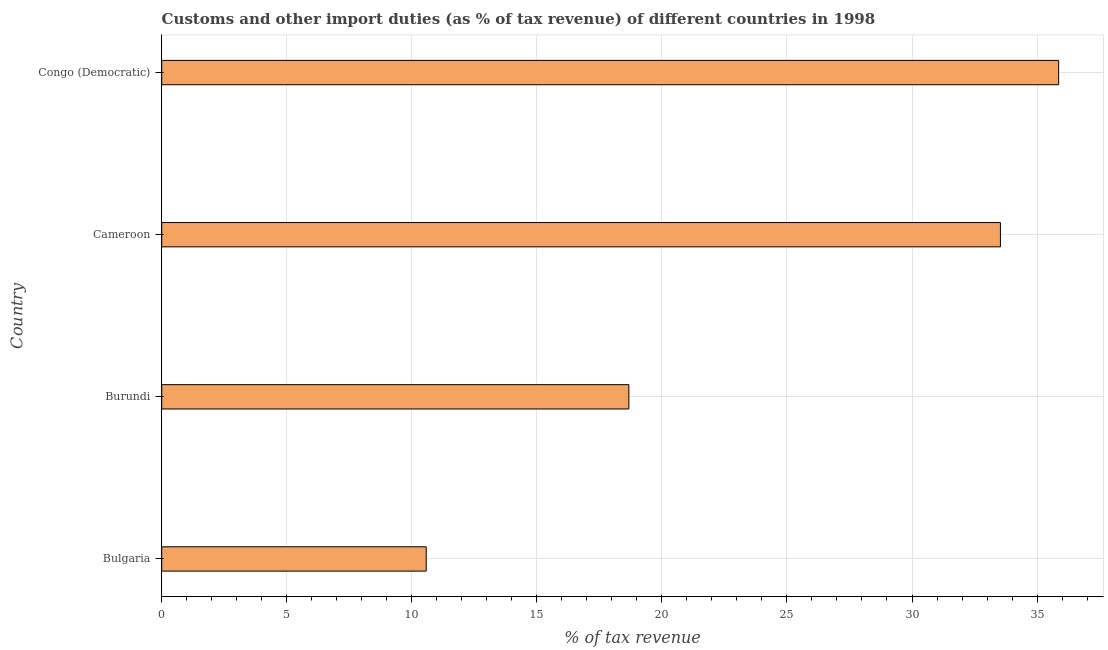Does the graph contain any zero values?
Keep it short and to the point. No. What is the title of the graph?
Keep it short and to the point. Customs and other import duties (as % of tax revenue) of different countries in 1998. What is the label or title of the X-axis?
Provide a succinct answer. % of tax revenue. What is the label or title of the Y-axis?
Give a very brief answer. Country. What is the customs and other import duties in Congo (Democratic)?
Offer a very short reply. 35.86. Across all countries, what is the maximum customs and other import duties?
Your answer should be very brief. 35.86. Across all countries, what is the minimum customs and other import duties?
Provide a short and direct response. 10.58. In which country was the customs and other import duties maximum?
Offer a terse response. Congo (Democratic). In which country was the customs and other import duties minimum?
Ensure brevity in your answer.  Bulgaria. What is the sum of the customs and other import duties?
Your answer should be very brief. 98.65. What is the difference between the customs and other import duties in Burundi and Congo (Democratic)?
Offer a very short reply. -17.18. What is the average customs and other import duties per country?
Your answer should be compact. 24.66. What is the median customs and other import duties?
Your response must be concise. 26.11. What is the ratio of the customs and other import duties in Burundi to that in Cameroon?
Make the answer very short. 0.56. Is the difference between the customs and other import duties in Burundi and Congo (Democratic) greater than the difference between any two countries?
Provide a succinct answer. No. What is the difference between the highest and the second highest customs and other import duties?
Give a very brief answer. 2.33. What is the difference between the highest and the lowest customs and other import duties?
Make the answer very short. 25.29. How many bars are there?
Your answer should be very brief. 4. How many countries are there in the graph?
Offer a very short reply. 4. What is the difference between two consecutive major ticks on the X-axis?
Offer a very short reply. 5. Are the values on the major ticks of X-axis written in scientific E-notation?
Provide a short and direct response. No. What is the % of tax revenue in Bulgaria?
Your response must be concise. 10.58. What is the % of tax revenue in Burundi?
Your answer should be compact. 18.68. What is the % of tax revenue of Cameroon?
Give a very brief answer. 33.54. What is the % of tax revenue of Congo (Democratic)?
Your answer should be very brief. 35.86. What is the difference between the % of tax revenue in Bulgaria and Burundi?
Your answer should be compact. -8.1. What is the difference between the % of tax revenue in Bulgaria and Cameroon?
Your response must be concise. -22.96. What is the difference between the % of tax revenue in Bulgaria and Congo (Democratic)?
Your answer should be very brief. -25.29. What is the difference between the % of tax revenue in Burundi and Cameroon?
Keep it short and to the point. -14.86. What is the difference between the % of tax revenue in Burundi and Congo (Democratic)?
Provide a succinct answer. -17.18. What is the difference between the % of tax revenue in Cameroon and Congo (Democratic)?
Give a very brief answer. -2.33. What is the ratio of the % of tax revenue in Bulgaria to that in Burundi?
Give a very brief answer. 0.57. What is the ratio of the % of tax revenue in Bulgaria to that in Cameroon?
Give a very brief answer. 0.32. What is the ratio of the % of tax revenue in Bulgaria to that in Congo (Democratic)?
Ensure brevity in your answer.  0.29. What is the ratio of the % of tax revenue in Burundi to that in Cameroon?
Provide a succinct answer. 0.56. What is the ratio of the % of tax revenue in Burundi to that in Congo (Democratic)?
Provide a short and direct response. 0.52. What is the ratio of the % of tax revenue in Cameroon to that in Congo (Democratic)?
Provide a short and direct response. 0.94. 